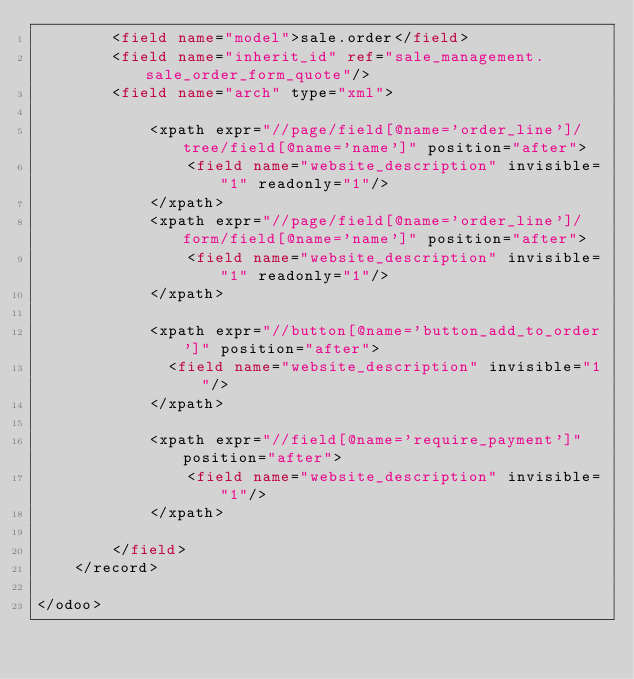Convert code to text. <code><loc_0><loc_0><loc_500><loc_500><_XML_>        <field name="model">sale.order</field>
        <field name="inherit_id" ref="sale_management.sale_order_form_quote"/>
        <field name="arch" type="xml">

            <xpath expr="//page/field[@name='order_line']/tree/field[@name='name']" position="after">
                <field name="website_description" invisible="1" readonly="1"/>
            </xpath>
            <xpath expr="//page/field[@name='order_line']/form/field[@name='name']" position="after">
                <field name="website_description" invisible="1" readonly="1"/>
            </xpath>

            <xpath expr="//button[@name='button_add_to_order']" position="after">
            	<field name="website_description" invisible="1"/>
            </xpath>

            <xpath expr="//field[@name='require_payment']" position="after">
                <field name="website_description" invisible="1"/>
            </xpath>

        </field>
    </record>

</odoo>
</code> 